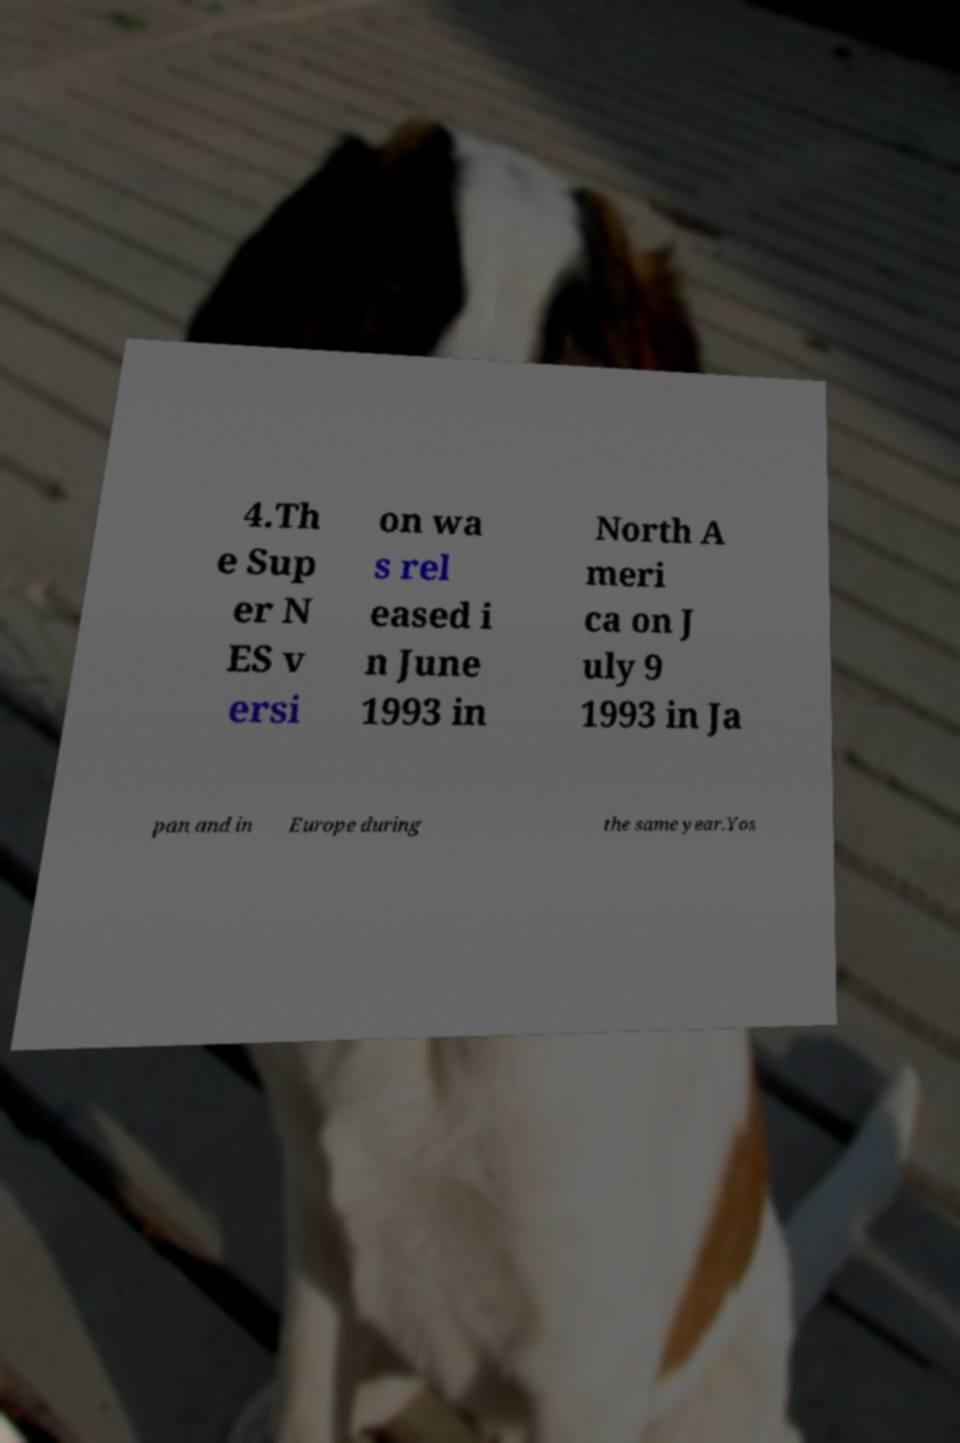I need the written content from this picture converted into text. Can you do that? 4.Th e Sup er N ES v ersi on wa s rel eased i n June 1993 in North A meri ca on J uly 9 1993 in Ja pan and in Europe during the same year.Yos 